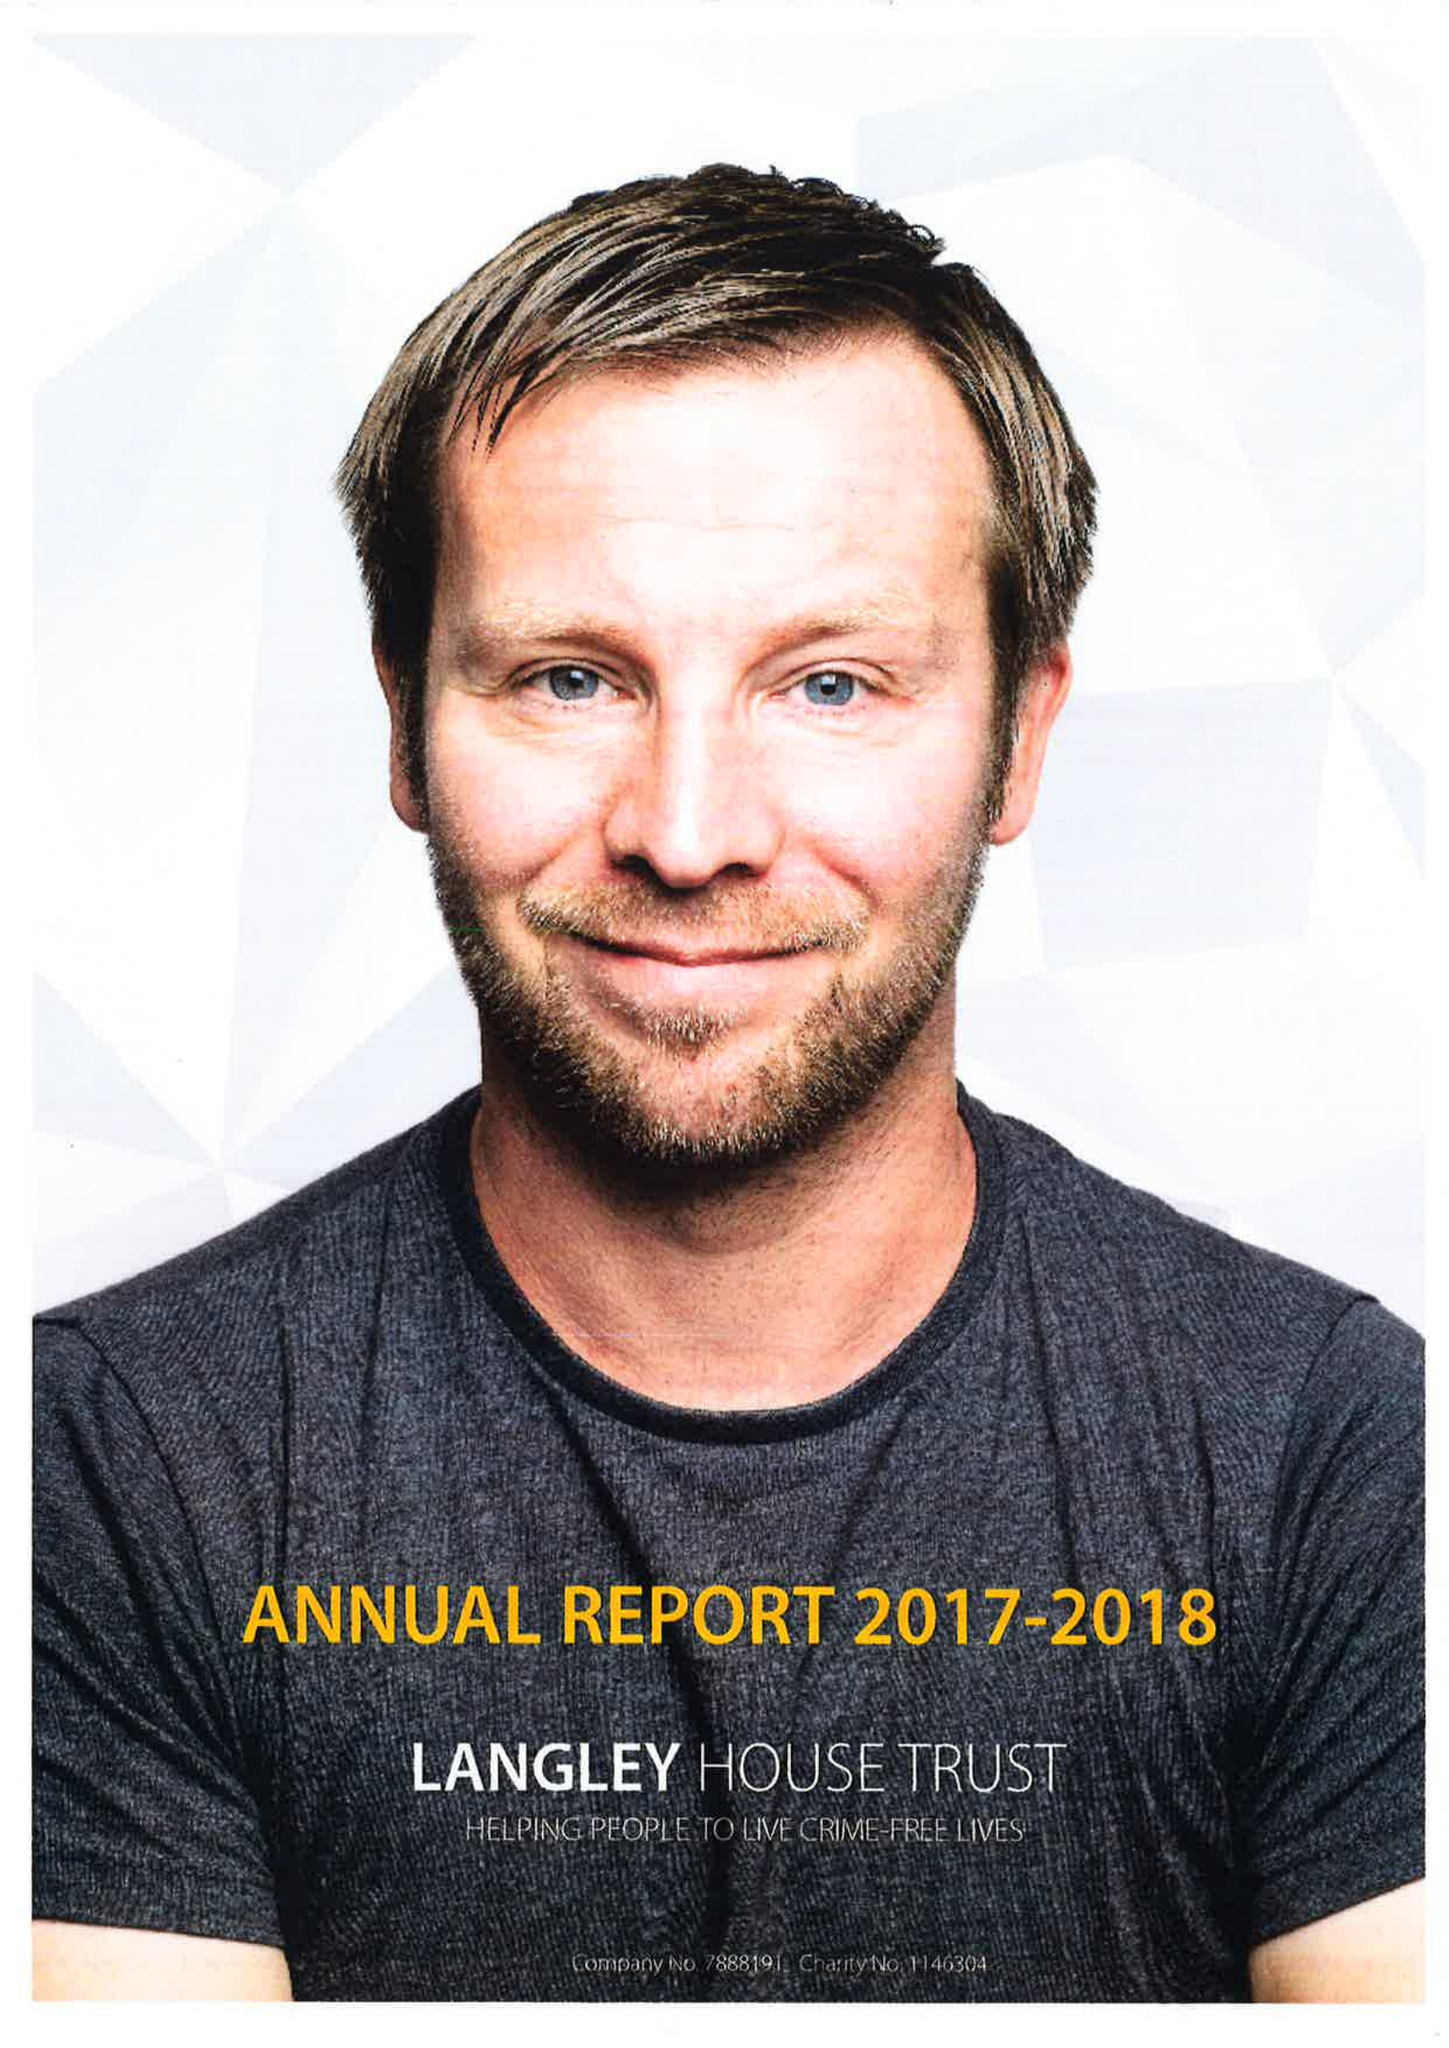What is the value for the charity_name?
Answer the question using a single word or phrase. Langley House Trust 